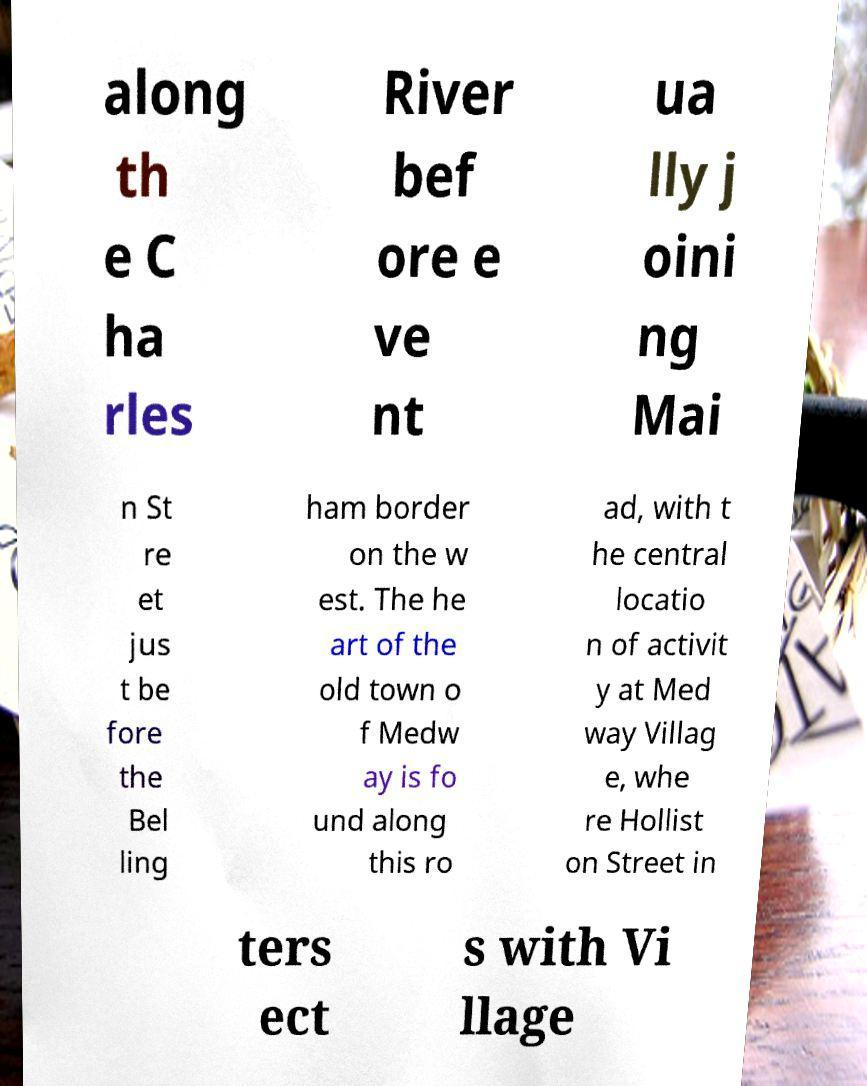Could you assist in decoding the text presented in this image and type it out clearly? along th e C ha rles River bef ore e ve nt ua lly j oini ng Mai n St re et jus t be fore the Bel ling ham border on the w est. The he art of the old town o f Medw ay is fo und along this ro ad, with t he central locatio n of activit y at Med way Villag e, whe re Hollist on Street in ters ect s with Vi llage 